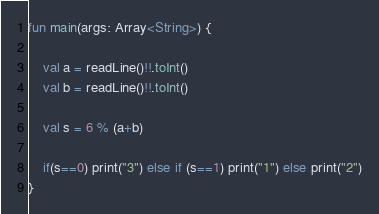Convert code to text. <code><loc_0><loc_0><loc_500><loc_500><_Kotlin_>fun main(args: Array<String>) {

    val a = readLine()!!.toInt()
    val b = readLine()!!.toInt()

    val s = 6 % (a+b)

    if(s==0) print("3") else if (s==1) print("1") else print("2")
}</code> 